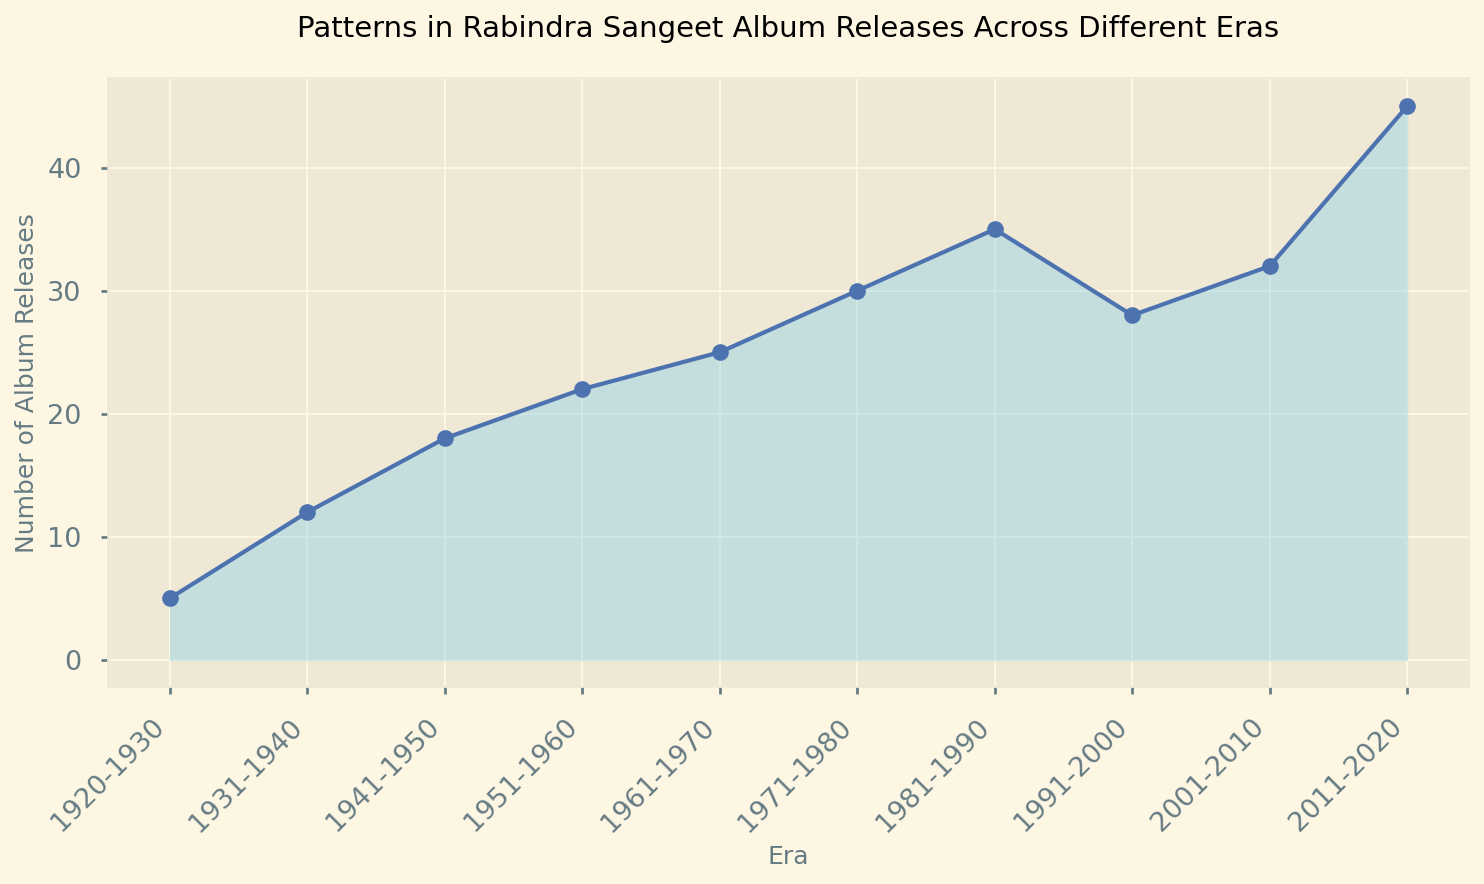What's the number of Rabindra Sangeet album releases in the 1951-1960 era? To find the answer, look for the data point corresponding to the 1951-1960 era on the x-axis and observe the height of the area chart above it or the label on the line plot. The number of album releases for this period is visible and marked.
Answer: 22 Which era saw the highest number of Rabindra Sangeet album releases? To determine this, compare the heights of the area segments for each era, looking for the highest peak in the chart. The tallest or most prominent peak represents the era with the highest number of releases.
Answer: 2011-2020 Compare the number of album releases between the eras 1971-1980 and 1991-2000. Which era had fewer releases and by how much? Identify the numbers of album releases for both 1971-1980 and 1991-2000 from the chart. Subtract the lower number from the higher number to find the difference. 1971-1980 had 30 releases, and 1991-2000 had 28 releases.
Answer: 1991-2000 had 2 fewer releases What's the total number of Rabindra Sangeet album releases during the first four eras (1920-1960)? Sum up the numbers corresponding to the first four eras from the chart: 1920-1930 (5), 1931-1940 (12), 1941-1950 (18), 1951-1960 (22). The total is calculated as 5 + 12 + 18 + 22.
Answer: 57 Was there a decline in album releases in any era compared to the previous one? If so, identify the era(s). Examine the trend of the chart lines or area heights, noting any downward slopes. Between the data points for each consecutive pair of eras, check where the value decreases. The visible decline is between 1981-1990 and 1991-2000.
Answer: 1991-2000 What is the average number of album releases per decade from 1920-2020? Sum the number of album releases across all eras and divide by the number of eras (decades). The total sum is the sum of all the given values: 5+12+18+22+25+30+35+28+32+45 = 252. There are 10 decades, so divide 252 by 10.
Answer: 25.2 By how much did the number of album releases increase from the 1941-1950 era to the 2011-2020 era? Subtract the number of album releases in the 1941-1950 era from that in the 2011-2020 era. 2011-2020 had 45 releases, while 1941-1950 had 18 releases. The increase is calculated as 45 - 18.
Answer: 27 Identify the era with the most significant growth in the number of album releases when compared to its immediate preceding era. Compare the difference in album releases between consecutive eras and find the largest increase. Calculate the differences and identify the maximum increment.
Answer: 2011-2020 How many more album releases were there in 1981-1990 compared to 1961-1970? Look at the number of album releases in 1961-1970 and 1981-1990 from the chart, then subtract the value for 1961-1970 from that of 1981-1990. 1981-1990 had 35 releases, and 1961-1970 had 25 releases.
Answer: 10 